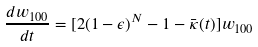<formula> <loc_0><loc_0><loc_500><loc_500>\frac { d w _ { 1 0 0 } } { d t } = [ 2 ( 1 - \epsilon ) ^ { N } - 1 - \bar { \kappa } ( t ) ] w _ { 1 0 0 }</formula> 